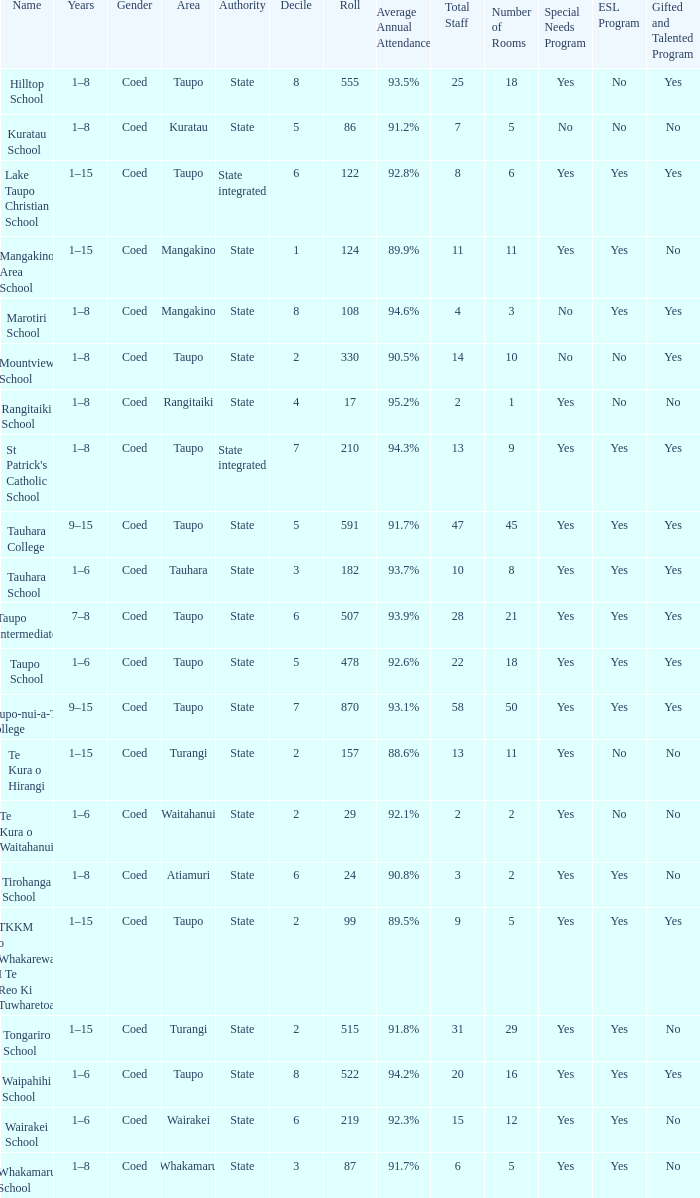Where is the school with state authority that has a roll of more than 157 students? Taupo, Taupo, Taupo, Tauhara, Taupo, Taupo, Taupo, Turangi, Taupo, Wairakei. 